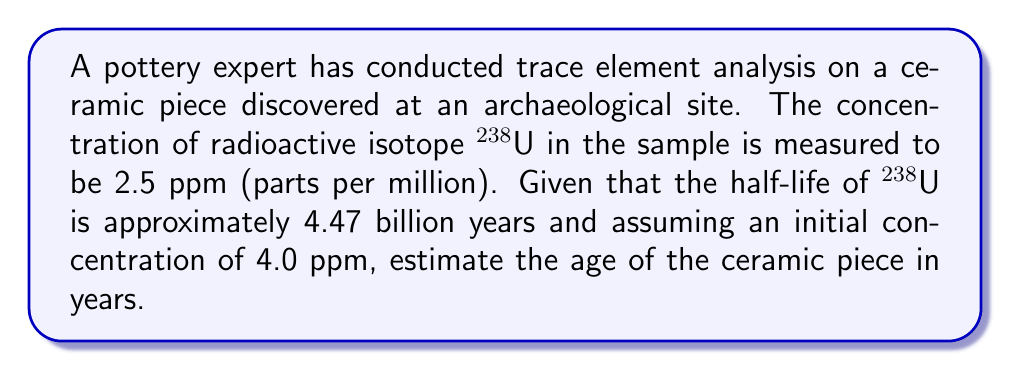What is the answer to this math problem? To estimate the age of the ceramic piece, we'll use the radioactive decay equation and solve it for time. The steps are as follows:

1) The radioactive decay equation is:

   $$N(t) = N_0 e^{-\lambda t}$$

   Where:
   $N(t)$ is the amount at time $t$
   $N_0$ is the initial amount
   $\lambda$ is the decay constant
   $t$ is time

2) We need to calculate $\lambda$ from the half-life:

   $$\lambda = \frac{\ln(2)}{t_{1/2}} = \frac{\ln(2)}{4.47 \times 10^9} \approx 1.55 \times 10^{-10} \text{ year}^{-1}$$

3) Now, let's substitute our known values into the decay equation:

   $$2.5 = 4.0 e^{-1.55 \times 10^{-10} t}$$

4) Divide both sides by 4.0:

   $$\frac{2.5}{4.0} = e^{-1.55 \times 10^{-10} t}$$

5) Take the natural log of both sides:

   $$\ln(\frac{2.5}{4.0}) = -1.55 \times 10^{-10} t$$

6) Solve for $t$:

   $$t = \frac{\ln(\frac{2.5}{4.0})}{-1.55 \times 10^{-10}} \approx 3.21 \times 10^9 \text{ years}$$

Therefore, the estimated age of the ceramic piece is approximately 3.21 billion years.
Answer: 3.21 billion years 